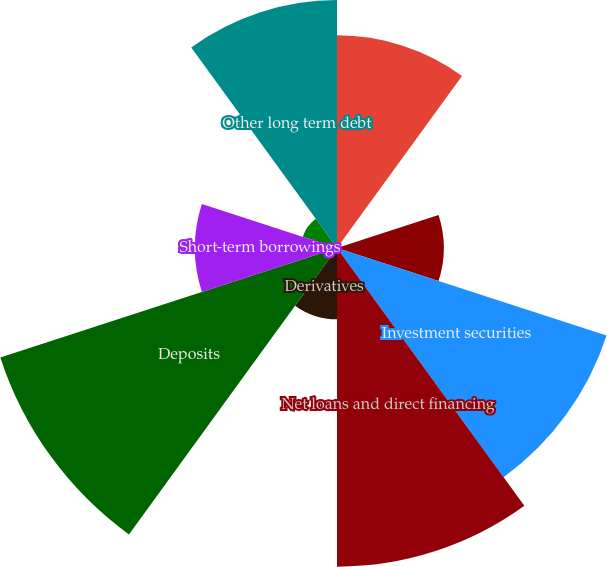Convert chart to OTSL. <chart><loc_0><loc_0><loc_500><loc_500><pie_chart><fcel>Cash and short-term assets<fcel>Trading account securities<fcel>Loans held for sale<fcel>Investment securities<fcel>Net loans and direct financing<fcel>Derivatives<fcel>Deposits<fcel>Short-term borrowings<fcel>Federal Home Loan Bank<fcel>Other long term debt<nl><fcel>11.99%<fcel>0.04%<fcel>6.02%<fcel>15.98%<fcel>17.97%<fcel>4.02%<fcel>19.96%<fcel>8.01%<fcel>2.03%<fcel>13.98%<nl></chart> 